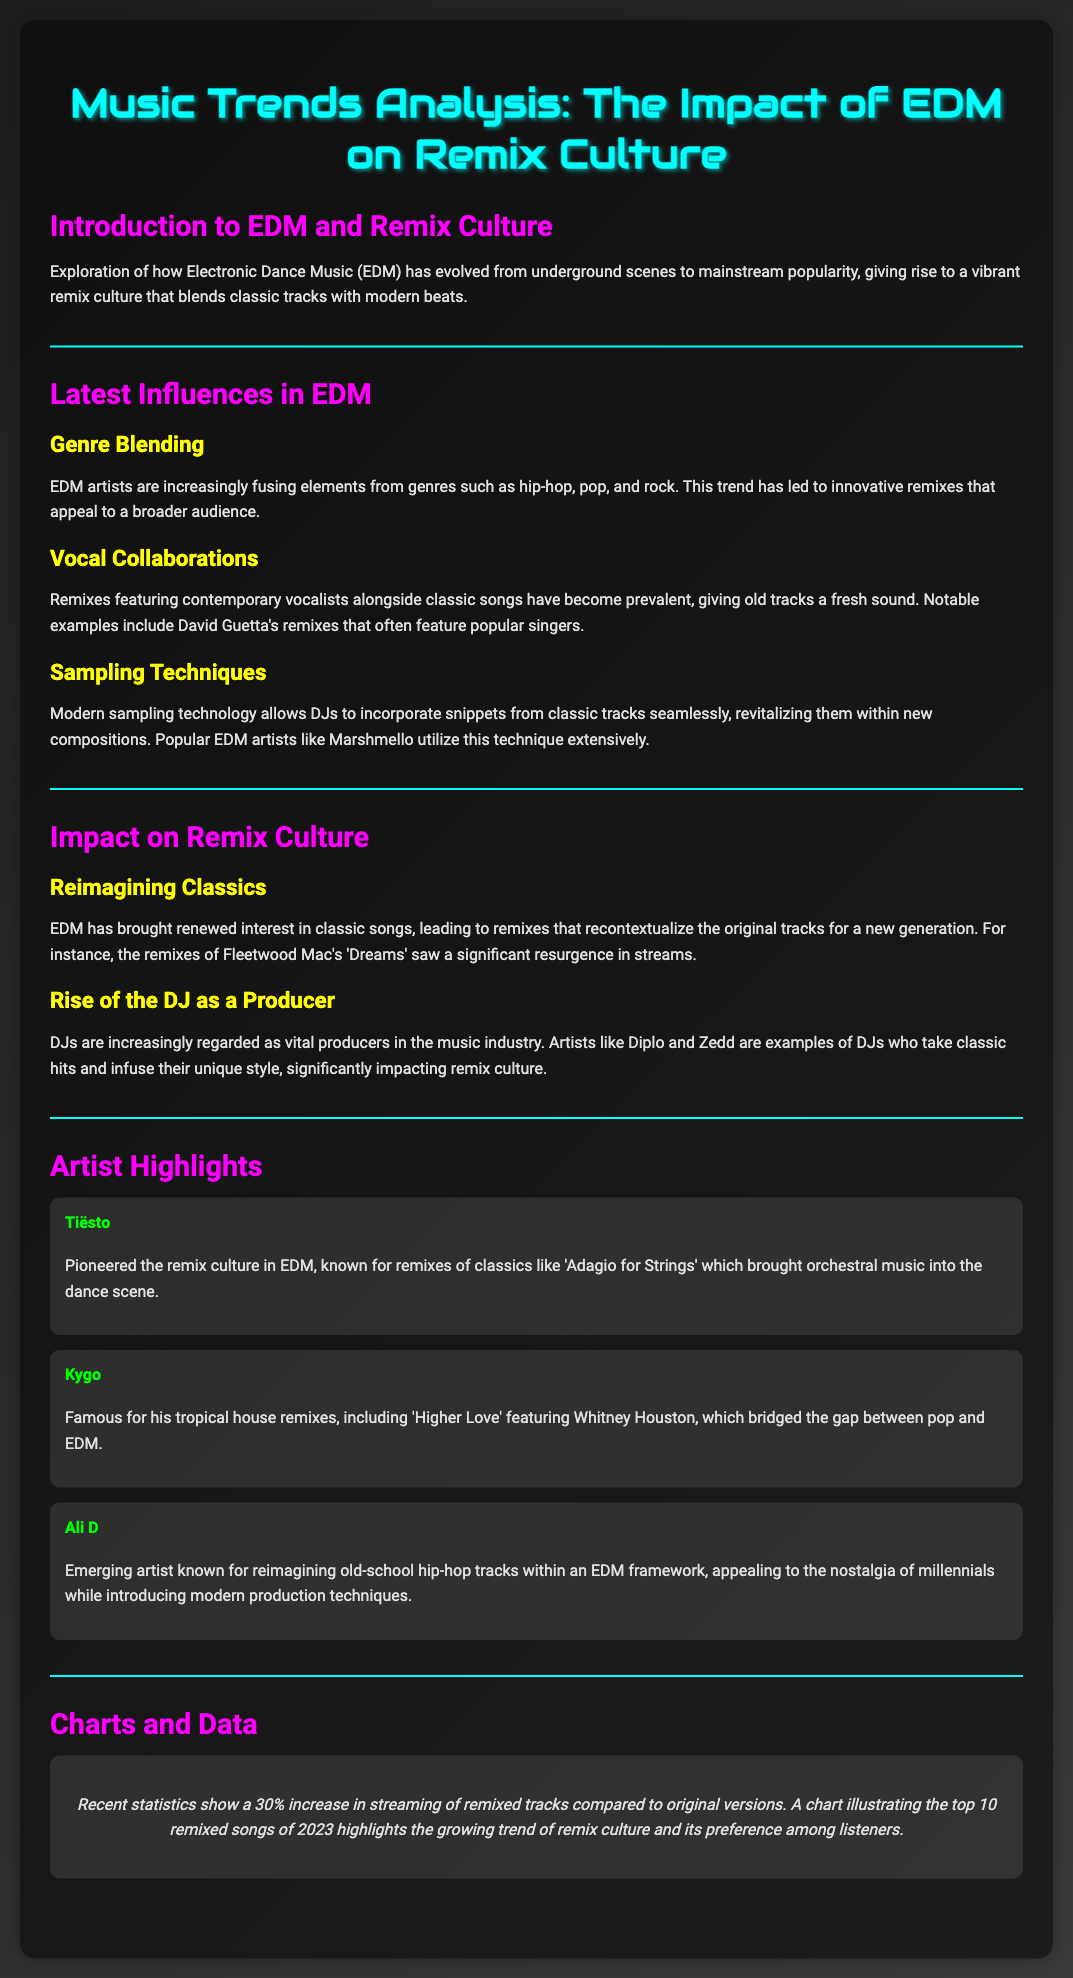What is the main genre discussed in the document? The main genre discussed is Electronic Dance Music (EDM), which has a significant influence on remix culture.
Answer: EDM Who is known for pioneering remix culture in EDM? Tiësto is highlighted as a pioneer of the remix culture in EDM, known for his remixes of classical pieces.
Answer: Tiësto What percentage increase in streaming of remixed tracks compared to original versions is mentioned? The document states there is a 30% increase in streaming of remixed tracks compared to original versions.
Answer: 30% Which classic song saw a significant resurgence due to EDM remixes? Fleetwood Mac's 'Dreams' is mentioned as experiencing a significant resurgence in streams due to remixes.
Answer: Dreams What technique do modern EDM artists use to incorporate classic tracks? Modern sampling technology is utilized by artists to incorporate snippets from classic tracks into new compositions.
Answer: Sampling techniques Which artist created the remix 'Higher Love' featuring Whitney Houston? Kygo created the remix 'Higher Love' featuring Whitney Houston.
Answer: Kygo What is the impact of vocal collaborations in remixes according to the document? Vocal collaborations in remixes have become prevalent, giving classic songs a fresh sound with contemporary vocalists.
Answer: Fresh sound What trend is seen in the role of DJs in the music industry? DJs are increasingly regarded as vital producers in the music industry, impacting remix culture significantly.
Answer: Vital producers What is the focus of the section titled "Latest Influences in EDM"? This section focuses on the blending of genres, vocal collaborations, and sampling techniques in EDM.
Answer: Genre Blending 